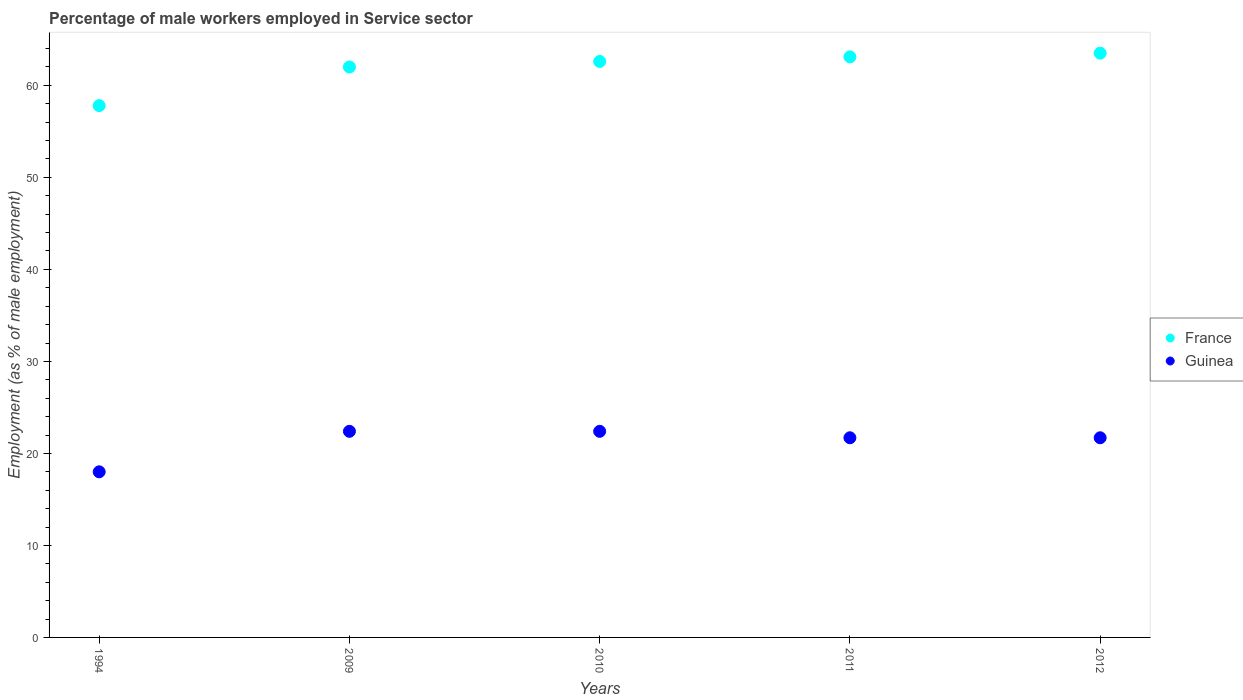How many different coloured dotlines are there?
Your answer should be compact. 2. What is the percentage of male workers employed in Service sector in Guinea in 2011?
Provide a short and direct response. 21.7. Across all years, what is the maximum percentage of male workers employed in Service sector in France?
Your answer should be very brief. 63.5. Across all years, what is the minimum percentage of male workers employed in Service sector in Guinea?
Offer a terse response. 18. What is the total percentage of male workers employed in Service sector in Guinea in the graph?
Offer a terse response. 106.2. What is the difference between the percentage of male workers employed in Service sector in Guinea in 1994 and that in 2009?
Offer a terse response. -4.4. What is the difference between the percentage of male workers employed in Service sector in Guinea in 2011 and the percentage of male workers employed in Service sector in France in 2009?
Provide a succinct answer. -40.3. What is the average percentage of male workers employed in Service sector in France per year?
Make the answer very short. 61.8. In the year 1994, what is the difference between the percentage of male workers employed in Service sector in Guinea and percentage of male workers employed in Service sector in France?
Offer a very short reply. -39.8. What is the ratio of the percentage of male workers employed in Service sector in France in 2009 to that in 2011?
Make the answer very short. 0.98. What is the difference between the highest and the second highest percentage of male workers employed in Service sector in France?
Keep it short and to the point. 0.4. What is the difference between the highest and the lowest percentage of male workers employed in Service sector in France?
Your answer should be compact. 5.7. Is the sum of the percentage of male workers employed in Service sector in Guinea in 2011 and 2012 greater than the maximum percentage of male workers employed in Service sector in France across all years?
Make the answer very short. No. How many years are there in the graph?
Provide a succinct answer. 5. How many legend labels are there?
Your answer should be compact. 2. What is the title of the graph?
Offer a very short reply. Percentage of male workers employed in Service sector. What is the label or title of the X-axis?
Your answer should be very brief. Years. What is the label or title of the Y-axis?
Make the answer very short. Employment (as % of male employment). What is the Employment (as % of male employment) in France in 1994?
Your answer should be very brief. 57.8. What is the Employment (as % of male employment) in Guinea in 1994?
Your response must be concise. 18. What is the Employment (as % of male employment) of France in 2009?
Your answer should be compact. 62. What is the Employment (as % of male employment) of Guinea in 2009?
Provide a succinct answer. 22.4. What is the Employment (as % of male employment) of France in 2010?
Offer a very short reply. 62.6. What is the Employment (as % of male employment) of Guinea in 2010?
Your answer should be very brief. 22.4. What is the Employment (as % of male employment) of France in 2011?
Give a very brief answer. 63.1. What is the Employment (as % of male employment) of Guinea in 2011?
Your answer should be very brief. 21.7. What is the Employment (as % of male employment) in France in 2012?
Your answer should be very brief. 63.5. What is the Employment (as % of male employment) of Guinea in 2012?
Offer a terse response. 21.7. Across all years, what is the maximum Employment (as % of male employment) of France?
Provide a succinct answer. 63.5. Across all years, what is the maximum Employment (as % of male employment) in Guinea?
Offer a very short reply. 22.4. Across all years, what is the minimum Employment (as % of male employment) in France?
Your answer should be very brief. 57.8. Across all years, what is the minimum Employment (as % of male employment) in Guinea?
Give a very brief answer. 18. What is the total Employment (as % of male employment) of France in the graph?
Make the answer very short. 309. What is the total Employment (as % of male employment) of Guinea in the graph?
Provide a succinct answer. 106.2. What is the difference between the Employment (as % of male employment) in France in 1994 and that in 2009?
Keep it short and to the point. -4.2. What is the difference between the Employment (as % of male employment) in Guinea in 1994 and that in 2009?
Provide a succinct answer. -4.4. What is the difference between the Employment (as % of male employment) in France in 1994 and that in 2010?
Provide a succinct answer. -4.8. What is the difference between the Employment (as % of male employment) of Guinea in 1994 and that in 2010?
Keep it short and to the point. -4.4. What is the difference between the Employment (as % of male employment) of France in 1994 and that in 2011?
Provide a succinct answer. -5.3. What is the difference between the Employment (as % of male employment) in Guinea in 1994 and that in 2011?
Keep it short and to the point. -3.7. What is the difference between the Employment (as % of male employment) of Guinea in 1994 and that in 2012?
Offer a terse response. -3.7. What is the difference between the Employment (as % of male employment) of Guinea in 2009 and that in 2010?
Make the answer very short. 0. What is the difference between the Employment (as % of male employment) in France in 2009 and that in 2011?
Provide a short and direct response. -1.1. What is the difference between the Employment (as % of male employment) of Guinea in 2009 and that in 2012?
Your answer should be compact. 0.7. What is the difference between the Employment (as % of male employment) of France in 2010 and that in 2011?
Give a very brief answer. -0.5. What is the difference between the Employment (as % of male employment) of France in 2011 and that in 2012?
Offer a very short reply. -0.4. What is the difference between the Employment (as % of male employment) in France in 1994 and the Employment (as % of male employment) in Guinea in 2009?
Your answer should be very brief. 35.4. What is the difference between the Employment (as % of male employment) of France in 1994 and the Employment (as % of male employment) of Guinea in 2010?
Offer a terse response. 35.4. What is the difference between the Employment (as % of male employment) in France in 1994 and the Employment (as % of male employment) in Guinea in 2011?
Give a very brief answer. 36.1. What is the difference between the Employment (as % of male employment) in France in 1994 and the Employment (as % of male employment) in Guinea in 2012?
Your answer should be very brief. 36.1. What is the difference between the Employment (as % of male employment) of France in 2009 and the Employment (as % of male employment) of Guinea in 2010?
Provide a short and direct response. 39.6. What is the difference between the Employment (as % of male employment) in France in 2009 and the Employment (as % of male employment) in Guinea in 2011?
Keep it short and to the point. 40.3. What is the difference between the Employment (as % of male employment) in France in 2009 and the Employment (as % of male employment) in Guinea in 2012?
Your answer should be compact. 40.3. What is the difference between the Employment (as % of male employment) in France in 2010 and the Employment (as % of male employment) in Guinea in 2011?
Give a very brief answer. 40.9. What is the difference between the Employment (as % of male employment) of France in 2010 and the Employment (as % of male employment) of Guinea in 2012?
Your response must be concise. 40.9. What is the difference between the Employment (as % of male employment) in France in 2011 and the Employment (as % of male employment) in Guinea in 2012?
Make the answer very short. 41.4. What is the average Employment (as % of male employment) in France per year?
Ensure brevity in your answer.  61.8. What is the average Employment (as % of male employment) in Guinea per year?
Your answer should be compact. 21.24. In the year 1994, what is the difference between the Employment (as % of male employment) of France and Employment (as % of male employment) of Guinea?
Your answer should be very brief. 39.8. In the year 2009, what is the difference between the Employment (as % of male employment) of France and Employment (as % of male employment) of Guinea?
Your answer should be very brief. 39.6. In the year 2010, what is the difference between the Employment (as % of male employment) of France and Employment (as % of male employment) of Guinea?
Offer a very short reply. 40.2. In the year 2011, what is the difference between the Employment (as % of male employment) of France and Employment (as % of male employment) of Guinea?
Offer a very short reply. 41.4. In the year 2012, what is the difference between the Employment (as % of male employment) of France and Employment (as % of male employment) of Guinea?
Your answer should be very brief. 41.8. What is the ratio of the Employment (as % of male employment) of France in 1994 to that in 2009?
Your answer should be compact. 0.93. What is the ratio of the Employment (as % of male employment) of Guinea in 1994 to that in 2009?
Your response must be concise. 0.8. What is the ratio of the Employment (as % of male employment) in France in 1994 to that in 2010?
Your response must be concise. 0.92. What is the ratio of the Employment (as % of male employment) of Guinea in 1994 to that in 2010?
Your answer should be very brief. 0.8. What is the ratio of the Employment (as % of male employment) in France in 1994 to that in 2011?
Ensure brevity in your answer.  0.92. What is the ratio of the Employment (as % of male employment) in Guinea in 1994 to that in 2011?
Ensure brevity in your answer.  0.83. What is the ratio of the Employment (as % of male employment) in France in 1994 to that in 2012?
Provide a short and direct response. 0.91. What is the ratio of the Employment (as % of male employment) of Guinea in 1994 to that in 2012?
Offer a very short reply. 0.83. What is the ratio of the Employment (as % of male employment) in Guinea in 2009 to that in 2010?
Your answer should be very brief. 1. What is the ratio of the Employment (as % of male employment) in France in 2009 to that in 2011?
Offer a terse response. 0.98. What is the ratio of the Employment (as % of male employment) in Guinea in 2009 to that in 2011?
Ensure brevity in your answer.  1.03. What is the ratio of the Employment (as % of male employment) of France in 2009 to that in 2012?
Provide a short and direct response. 0.98. What is the ratio of the Employment (as % of male employment) of Guinea in 2009 to that in 2012?
Make the answer very short. 1.03. What is the ratio of the Employment (as % of male employment) in France in 2010 to that in 2011?
Your answer should be compact. 0.99. What is the ratio of the Employment (as % of male employment) in Guinea in 2010 to that in 2011?
Ensure brevity in your answer.  1.03. What is the ratio of the Employment (as % of male employment) in France in 2010 to that in 2012?
Provide a succinct answer. 0.99. What is the ratio of the Employment (as % of male employment) of Guinea in 2010 to that in 2012?
Ensure brevity in your answer.  1.03. What is the difference between the highest and the second highest Employment (as % of male employment) in Guinea?
Provide a short and direct response. 0. 